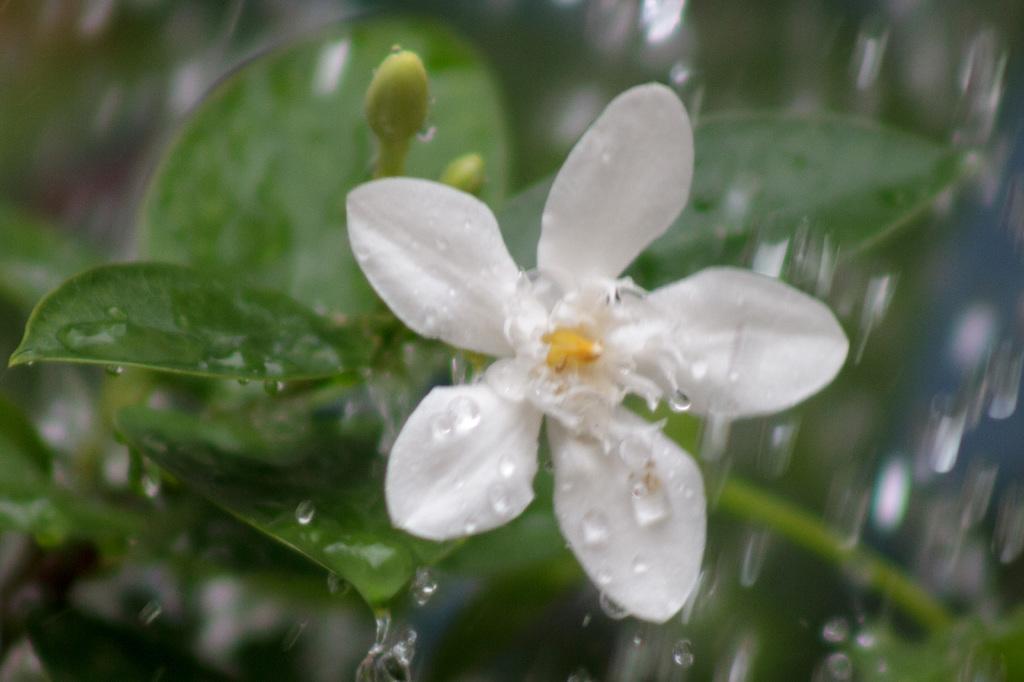Please provide a concise description of this image. There is a white color flower with leaves. On that there are water droplets. 